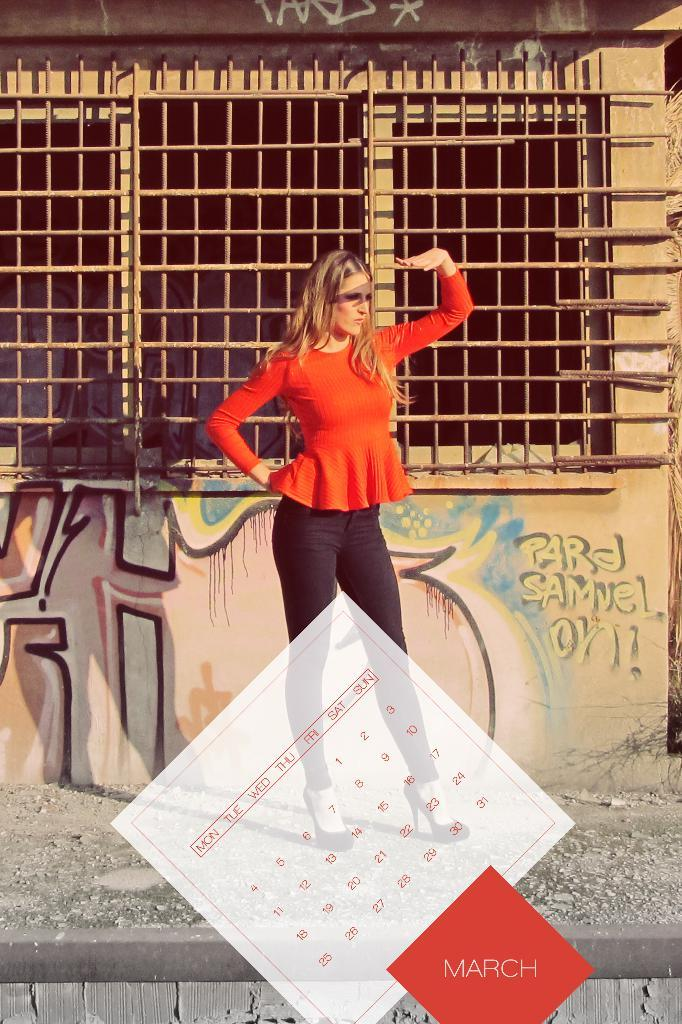What is the main subject of the image? There is a person standing in the image. Where is the person standing? The person is standing on the ground. What can be seen on the wall in the image? There is a wall with art in the image. Is the art visible on the wall? Yes, the art is visible on the wall. What other object can be seen at the bottom of the image? There is a calendar in the bottom side of the image. What language is spoken by the person in the image? There is no information about the language spoken by the person in the image. --- Facts: 1. There is a person sitting in the image. 2. The person is sitting on a chair. 3. The chair is made of wood. 4. There is a table in front of the person. 5. There is a laptop on the table. Absurd Topics: elephant, piano, ocean Conversation: What is the main subject of the image? There is a person sitting in the image. What is the person sitting on? The person is sitting on a chair. What is the chair made of? The chair is made of wood. What is in front of the person? There is a table in front of the person. What is on the table? There is a laptop on the table. Reasoning: Let's think step by step in order to produce the conversation. We start by identifying the main subject of the image, which is the person sitting. Then, we describe the person's location and surroundings, including the chair and its material (wood). Next, we observe the objects in front of the person, which is the table. Finally, we describe the object on the table, which is a laptop. Absurd Question/Answer: Can you hear the elephant playing the piano in the image? There is no elephant, piano, or ocean present in the image. 